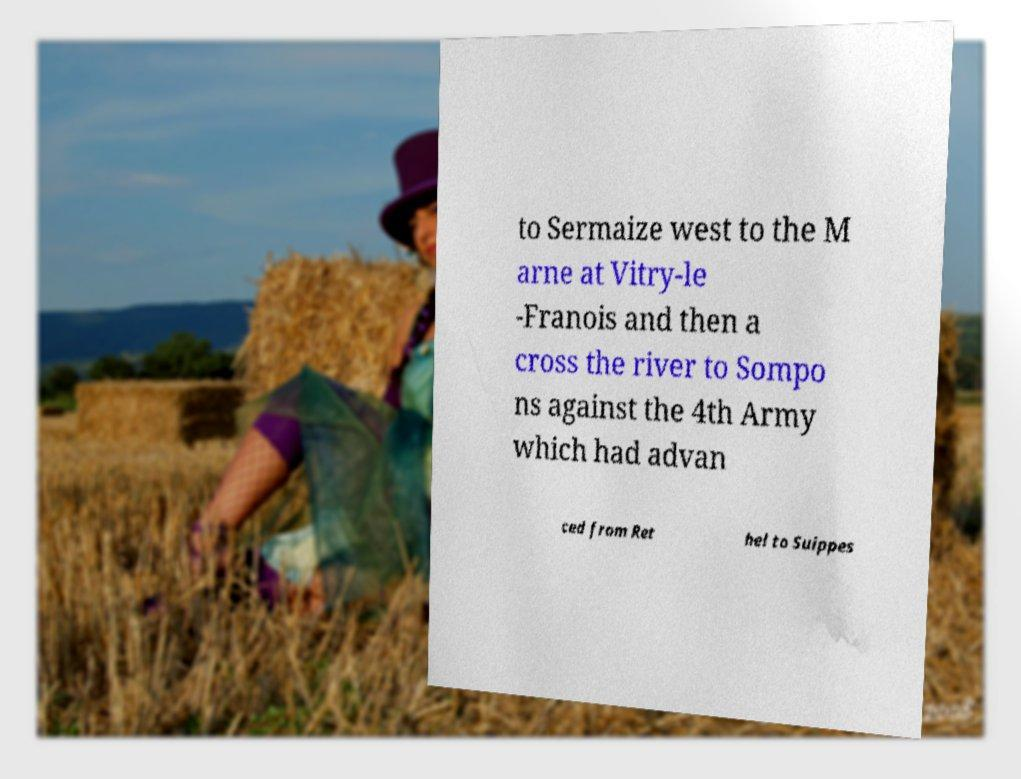Could you assist in decoding the text presented in this image and type it out clearly? to Sermaize west to the M arne at Vitry-le -Franois and then a cross the river to Sompo ns against the 4th Army which had advan ced from Ret hel to Suippes 